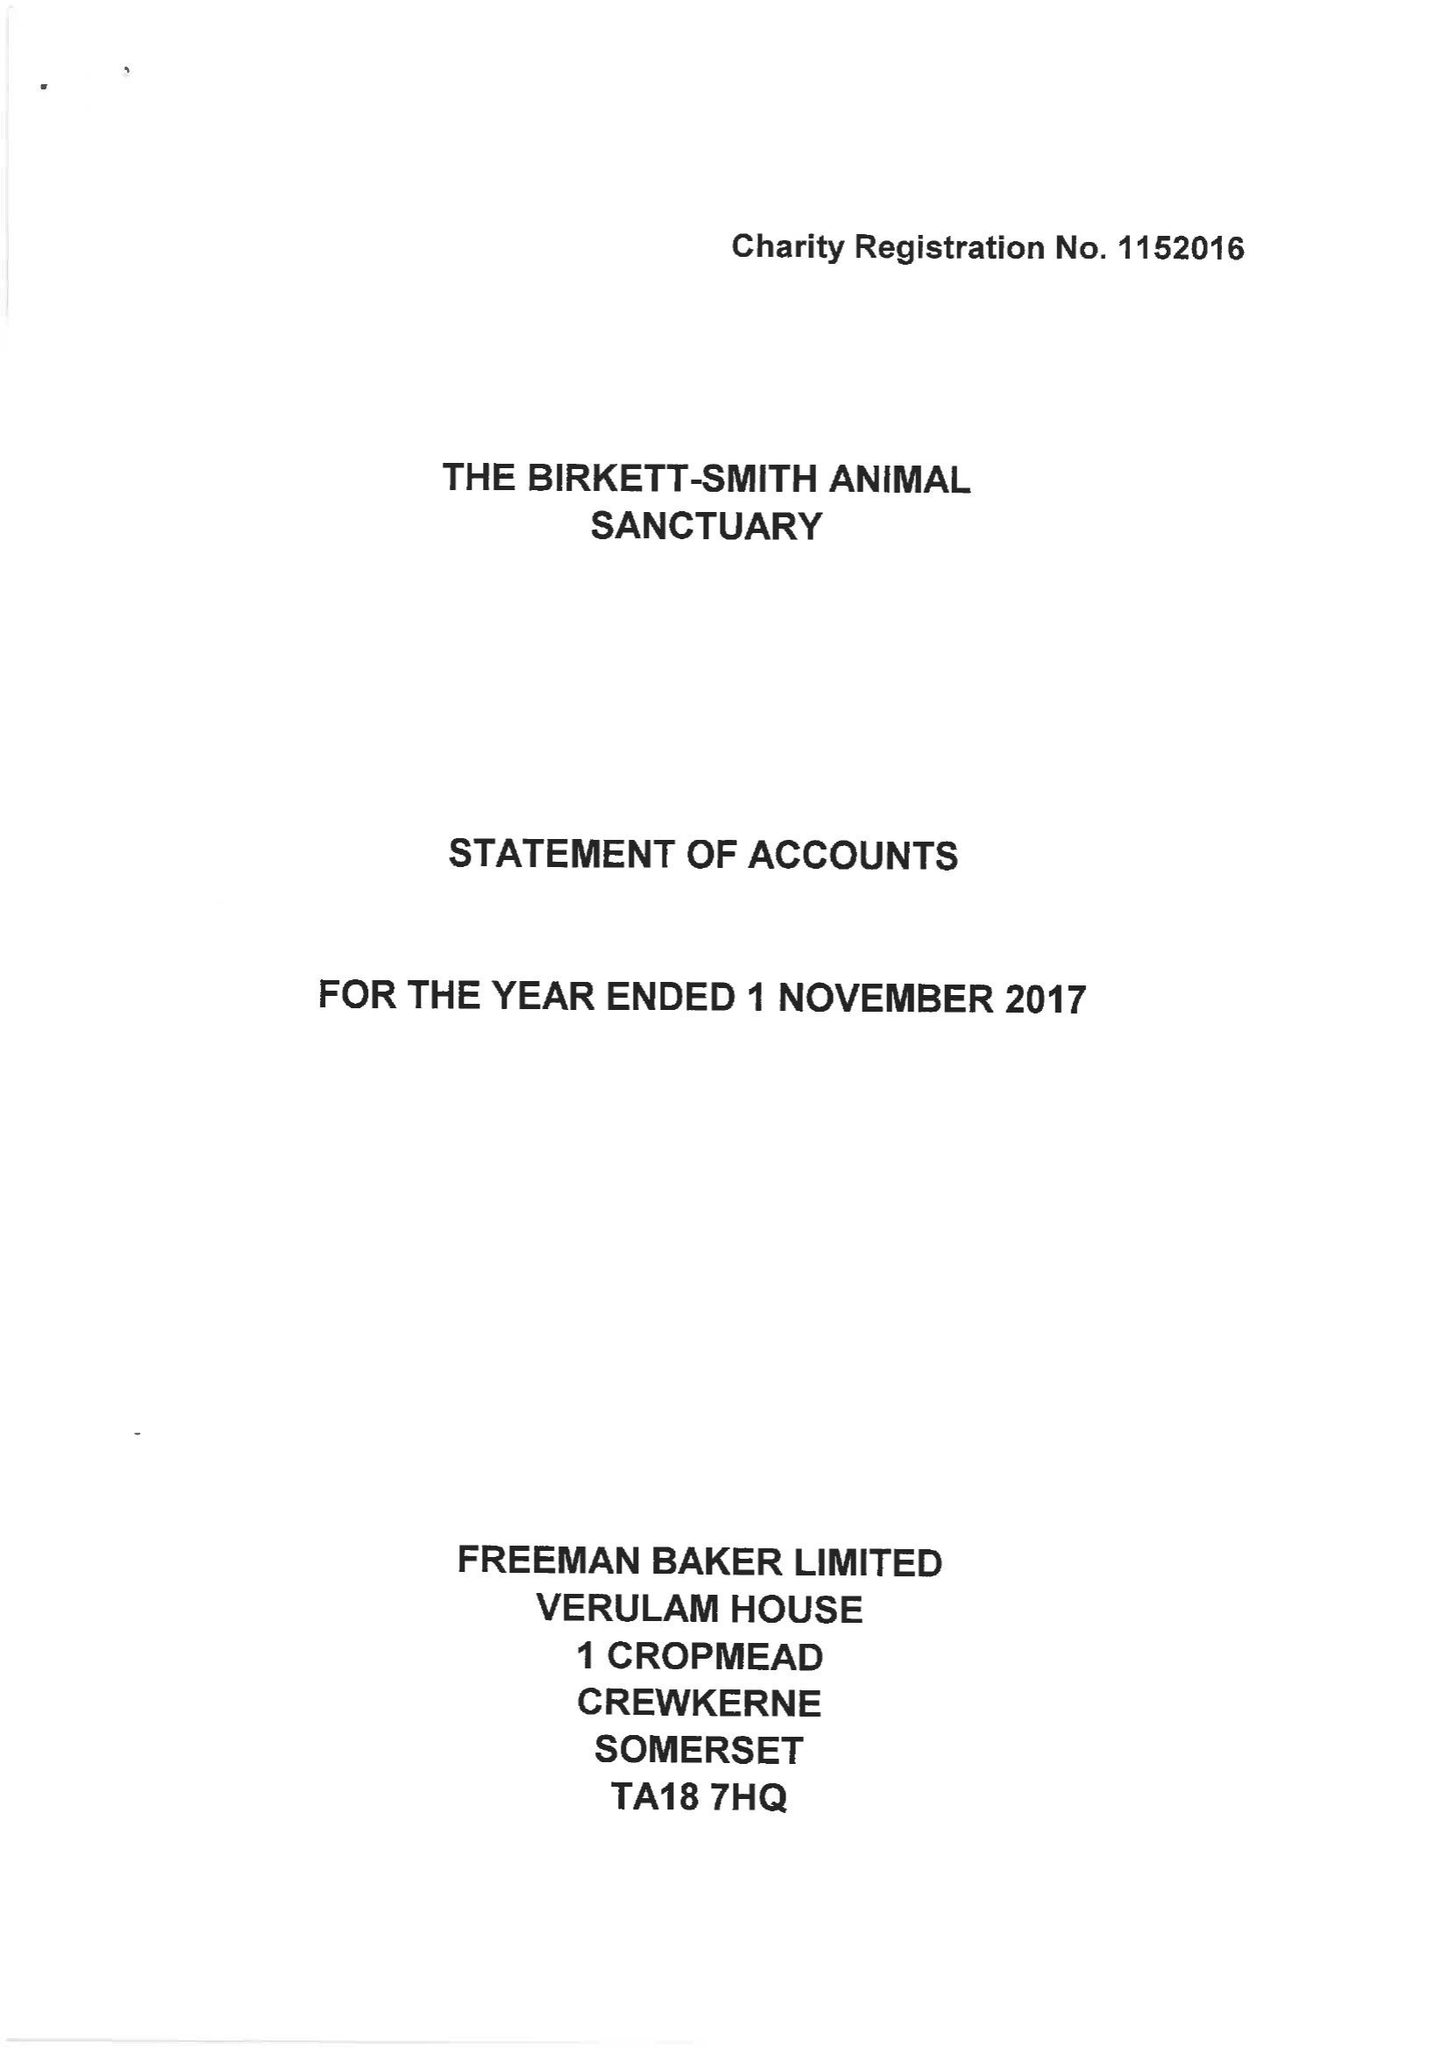What is the value for the address__street_line?
Answer the question using a single word or phrase. None 